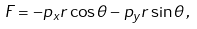Convert formula to latex. <formula><loc_0><loc_0><loc_500><loc_500>F = - p _ { x } r \cos \theta - p _ { y } r \sin \theta \, ,</formula> 